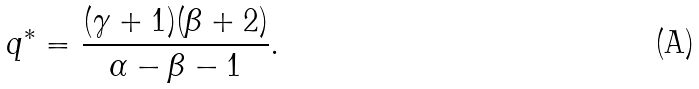<formula> <loc_0><loc_0><loc_500><loc_500>q ^ { * } = \frac { ( \gamma + 1 ) ( \beta + 2 ) } { \alpha - \beta - 1 } .</formula> 